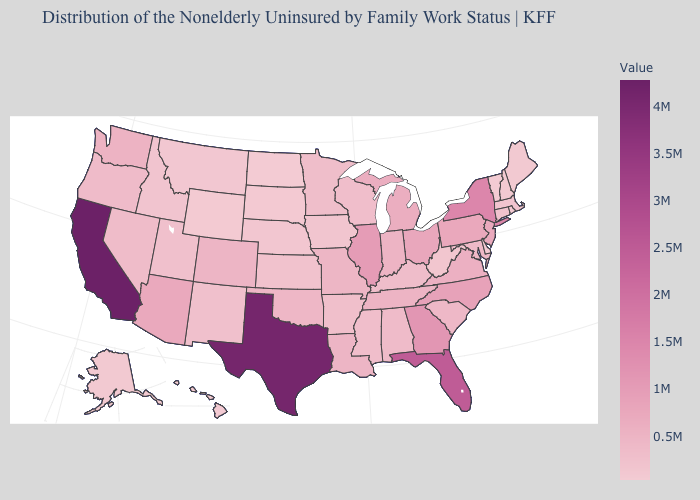Which states have the lowest value in the USA?
Keep it brief. Vermont. Does Hawaii have the lowest value in the West?
Give a very brief answer. Yes. Is the legend a continuous bar?
Concise answer only. Yes. Which states have the highest value in the USA?
Concise answer only. California. 